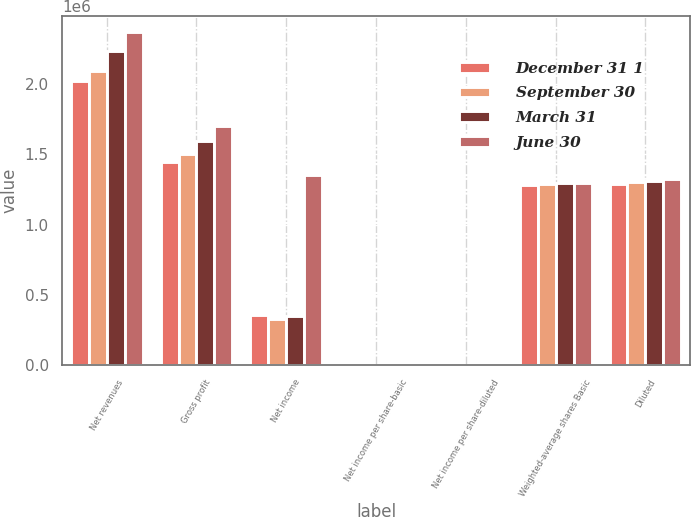Convert chart to OTSL. <chart><loc_0><loc_0><loc_500><loc_500><stacked_bar_chart><ecel><fcel>Net revenues<fcel>Gross profit<fcel>Net income<fcel>Net income per share-basic<fcel>Net income per share-diluted<fcel>Weighted-average shares Basic<fcel>Diluted<nl><fcel>December 31 1<fcel>2.02059e+06<fcel>1.4472e+06<fcel>357113<fcel>0.28<fcel>0.28<fcel>1.28381e+06<fcel>1.28781e+06<nl><fcel>September 30<fcel>2.09799e+06<fcel>1.50622e+06<fcel>327342<fcel>0.25<fcel>0.25<fcel>1.28882e+06<fcel>1.30043e+06<nl><fcel>March 31<fcel>2.23785e+06<fcel>1.59394e+06<fcel>349736<fcel>0.27<fcel>0.27<fcel>1.29351e+06<fcel>1.31127e+06<nl><fcel>June 30<fcel>2.37093e+06<fcel>1.70024e+06<fcel>1.35491e+06<fcel>1.05<fcel>1.02<fcel>1.29554e+06<fcel>1.32269e+06<nl></chart> 